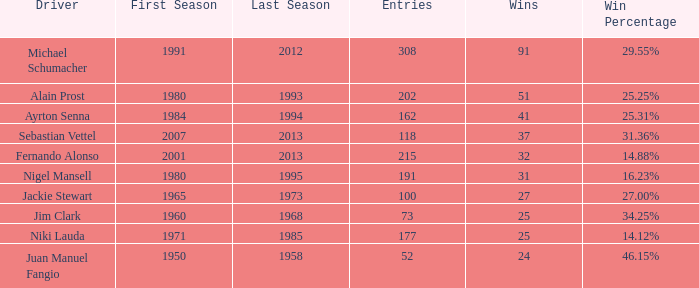Which season did jackie stewart enter with entries less than 215? 1965 – 1973. 